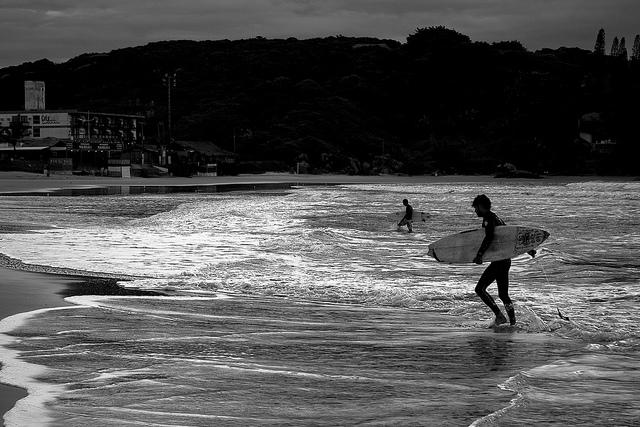Is this a black and white photo?
Quick response, please. Yes. Is the water blue?
Concise answer only. No. Is there water?
Quick response, please. Yes. How many surfers are there?
Give a very brief answer. 2. What is the kid holding?
Answer briefly. Surfboard. What color is the water?
Quick response, please. Gray. What sport are they engaging in?
Give a very brief answer. Surfing. What is this person holding?
Be succinct. Surfboard. 